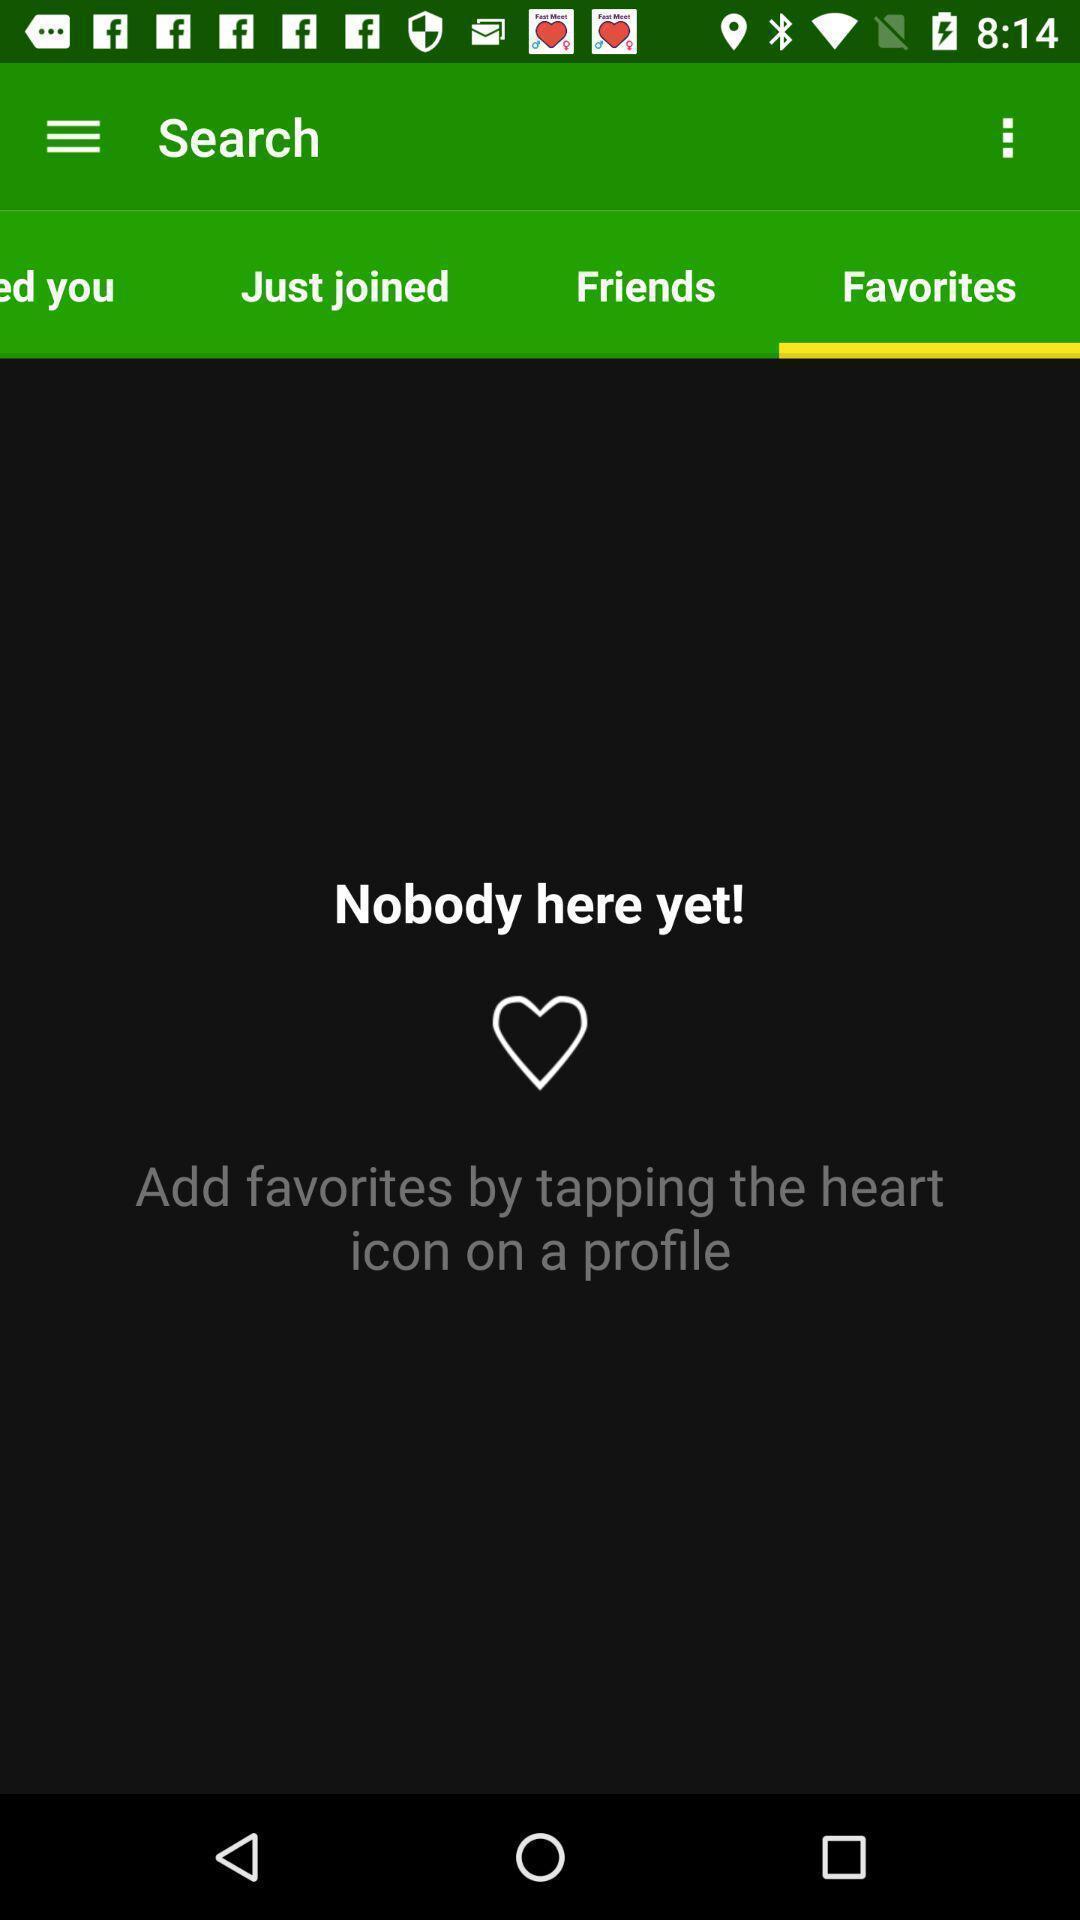Provide a description of this screenshot. Page showing different options on an app. 